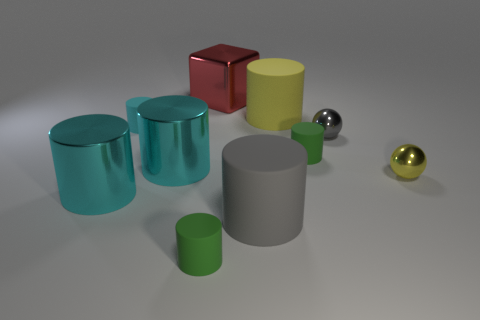How many cyan cylinders must be subtracted to get 1 cyan cylinders? 2 Subtract all tiny matte cylinders. How many cylinders are left? 4 Subtract all gray balls. How many balls are left? 1 Subtract 1 spheres. How many spheres are left? 1 Subtract all cyan blocks. How many green cylinders are left? 2 Subtract all cylinders. How many objects are left? 3 Subtract all red cylinders. Subtract all red spheres. How many cylinders are left? 7 Subtract all large cyan objects. Subtract all big yellow matte cylinders. How many objects are left? 7 Add 6 large rubber cylinders. How many large rubber cylinders are left? 8 Add 2 large things. How many large things exist? 7 